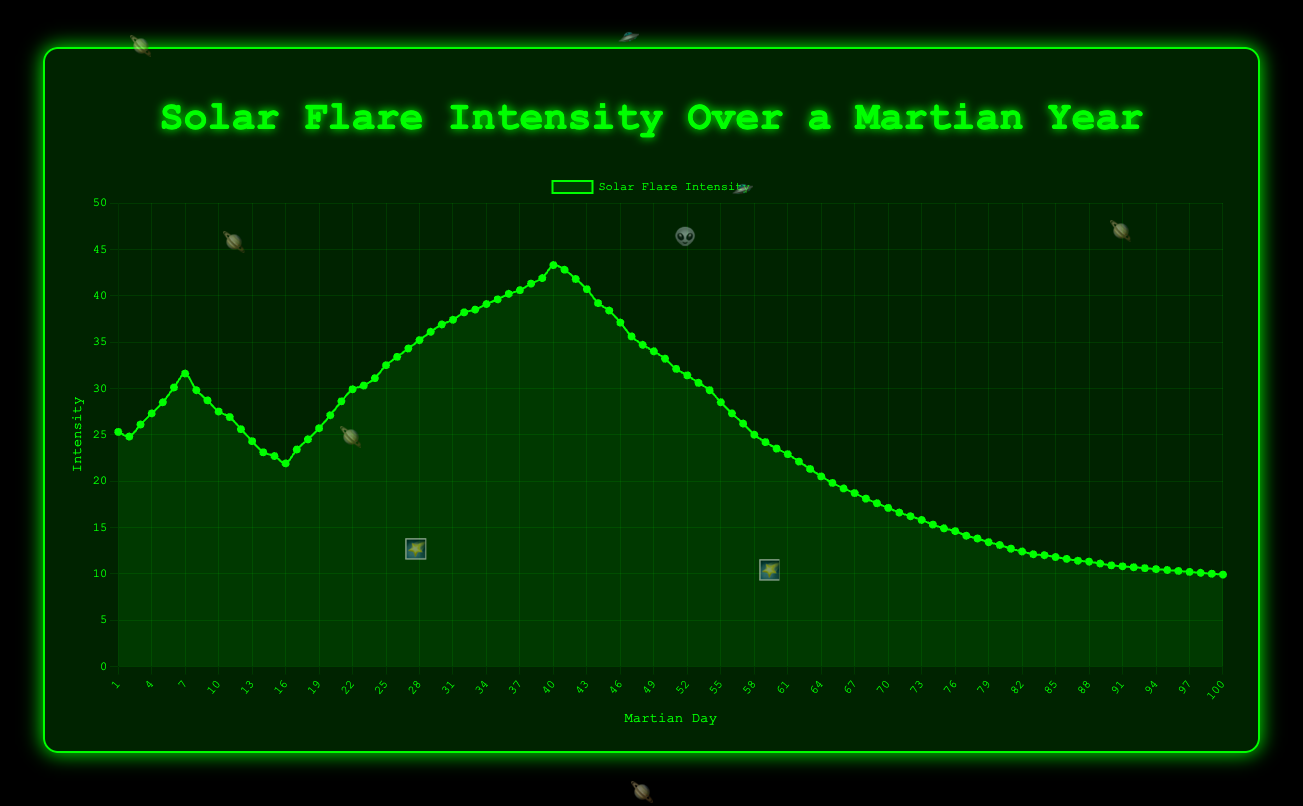What is the overall trend observed in the solar flare intensity during the first 40 Martian days? Initially, the solar flare intensity increases gradually, starting from around 25.3 units on Martian Day 1 and reaching its peak at around 43.3 units on Martian Day 40.
Answer: It increases What is the difference in intensity between Martian Day 10 and Martian Day 5? On Martian Day 10, the intensity is 27.5 units, and on Martian Day 5, it is 28.5 units. The difference is 27.5 - 28.5 = -1.0.
Answer: -1.0 Which Martian day has the highest recorded solar flare intensity? The highest recorded solar flare intensity is on Martian Day 40 with an intensity of 43.3 units.
Answer: Martian Day 40 Describe the pattern of solar flare intensity after the peak on Martian Day 40. After the peak on Martian Day 40, the solar flare intensity begins to decrease, continuing this downward trend until Martian Day 100.
Answer: It decreases Between which two consecutive Martian days is the largest drop in solar flare intensity observed? The largest drop is observed between Martian Day 40 (43.3) and Martian Day 41 (42.8). The drop is 43.3 - 42.8 = 0.5.
Answer: Martian Day 40 and 41 What is the average solar flare intensity over the entire 100 Martian days? Sum all intensities and divide by 100. Total sum = 2511.2, Average = 2511.2 / 100 = 25.112.
Answer: 25.112 By how much does the intensity decrease from Martian Day 25 to Martian Day 30? On Martian Day 25, the intensity is 32.5 units, and on Martian Day 30, it is 36.9 units. The change is 36.9 - 32.5 = 4.4 units.
Answer: 4.4 What is the median value of the solar flare intensity in the dataset? Sort the intensities and find the middle value. The median of 100 values is the average of the 50th and 51st values. Median = (33.2 + 32.1) / 2 = 32.65.
Answer: 32.65 Compare the solar flare intensity on Martian Day 1 and Martian Day 100. On Martian Day 1, the intensity is 25.3 units, and on Martian Day 100, it is 9.9 units. The intensity on Martian Day 1 is higher.
Answer: Martian Day 1 Identify the period with the longest continuous increase in solar flare intensity. The longest continuous increase is from Martian Day 14 (23.1) to Martian Day 40 (43.3). During this period, the intensity steadily rises.
Answer: Day 14 to Day 40 